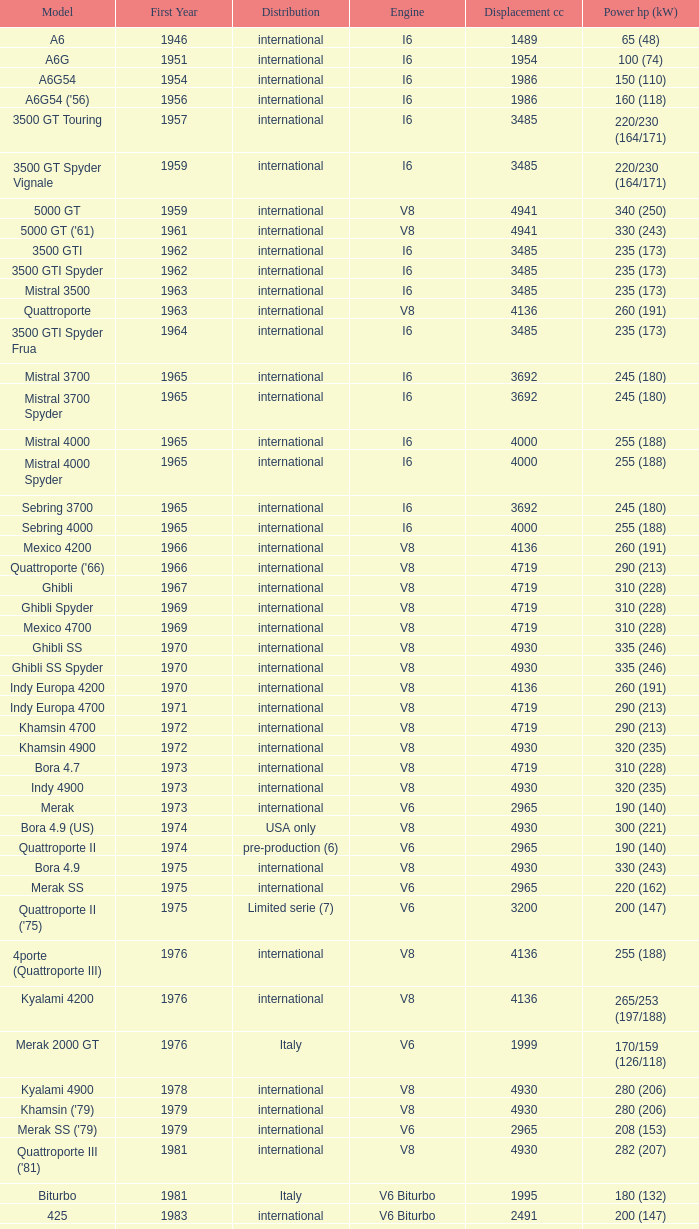When does the "quattroporte (2.8)" model have its earliest first year? 1994.0. 